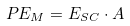<formula> <loc_0><loc_0><loc_500><loc_500>P E _ { M } = E _ { S C } \cdot A</formula> 